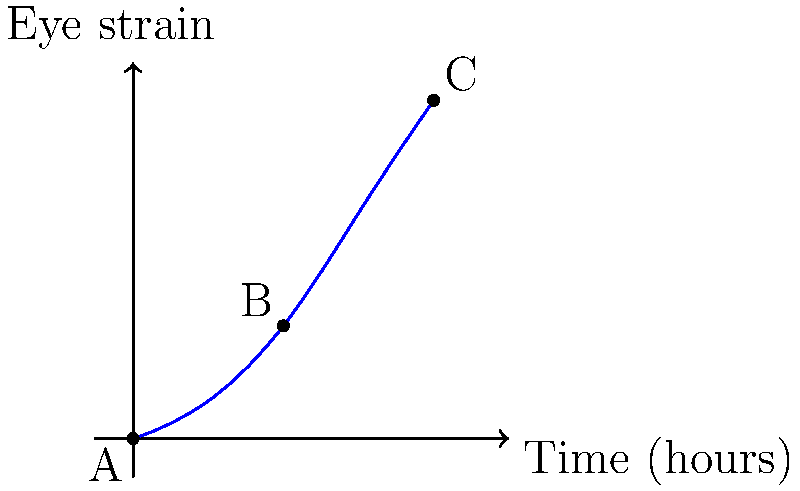During an intense gaming session of Sins of a Solar Empire, the graph shows the relationship between time spent gaming and eye strain. Point A represents the start of the session, B is the 2-hour mark, and C is the 4-hour mark. Calculate the rate of change in eye strain between points B and C. To calculate the rate of change in eye strain between points B and C, we need to follow these steps:

1. Identify the coordinates of points B and C:
   Point B: (2, 1.5)
   Point C: (4, 4.5)

2. Calculate the change in eye strain (vertical change):
   $\Delta y = y_C - y_B = 4.5 - 1.5 = 3$

3. Calculate the change in time (horizontal change):
   $\Delta x = x_C - x_B = 4 - 2 = 2$ hours

4. Use the formula for rate of change:
   Rate of change = $\frac{\Delta y}{\Delta x}$

5. Substitute the values:
   Rate of change = $\frac{3}{2}$ = 1.5

6. Interpret the result:
   The rate of change in eye strain between points B and C is 1.5 units of eye strain per hour.

This means that during the last two hours of the gaming session, the player's eye strain increased at a rate of 1.5 units per hour, which is faster than the initial two hours. This acceleration in eye strain could be due to fatigue and prolonged focus on the game screen.
Answer: 1.5 units/hour 